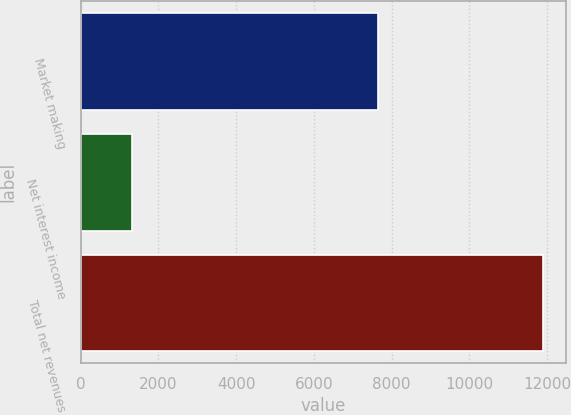Convert chart. <chart><loc_0><loc_0><loc_500><loc_500><bar_chart><fcel>Market making<fcel>Net interest income<fcel>Total net revenues<nl><fcel>7660<fcel>1322<fcel>11902<nl></chart> 